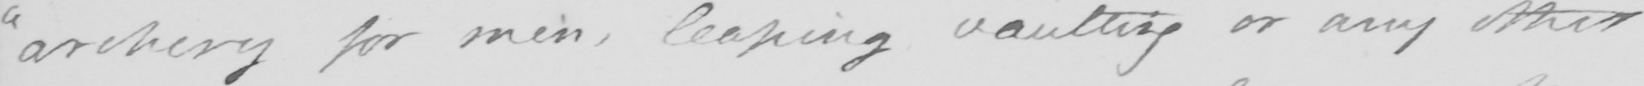Transcribe the text shown in this historical manuscript line. " archery for men , leaping vaulting or any other 